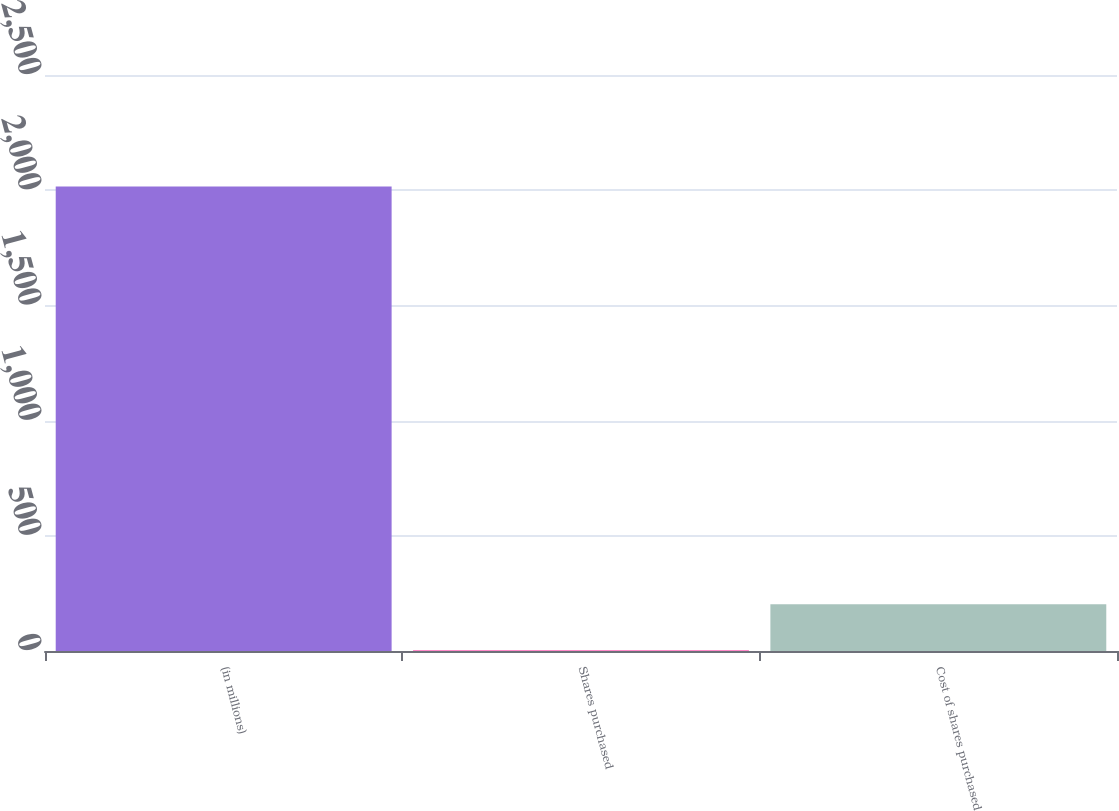Convert chart to OTSL. <chart><loc_0><loc_0><loc_500><loc_500><bar_chart><fcel>(in millions)<fcel>Shares purchased<fcel>Cost of shares purchased<nl><fcel>2016<fcel>1.8<fcel>203.22<nl></chart> 